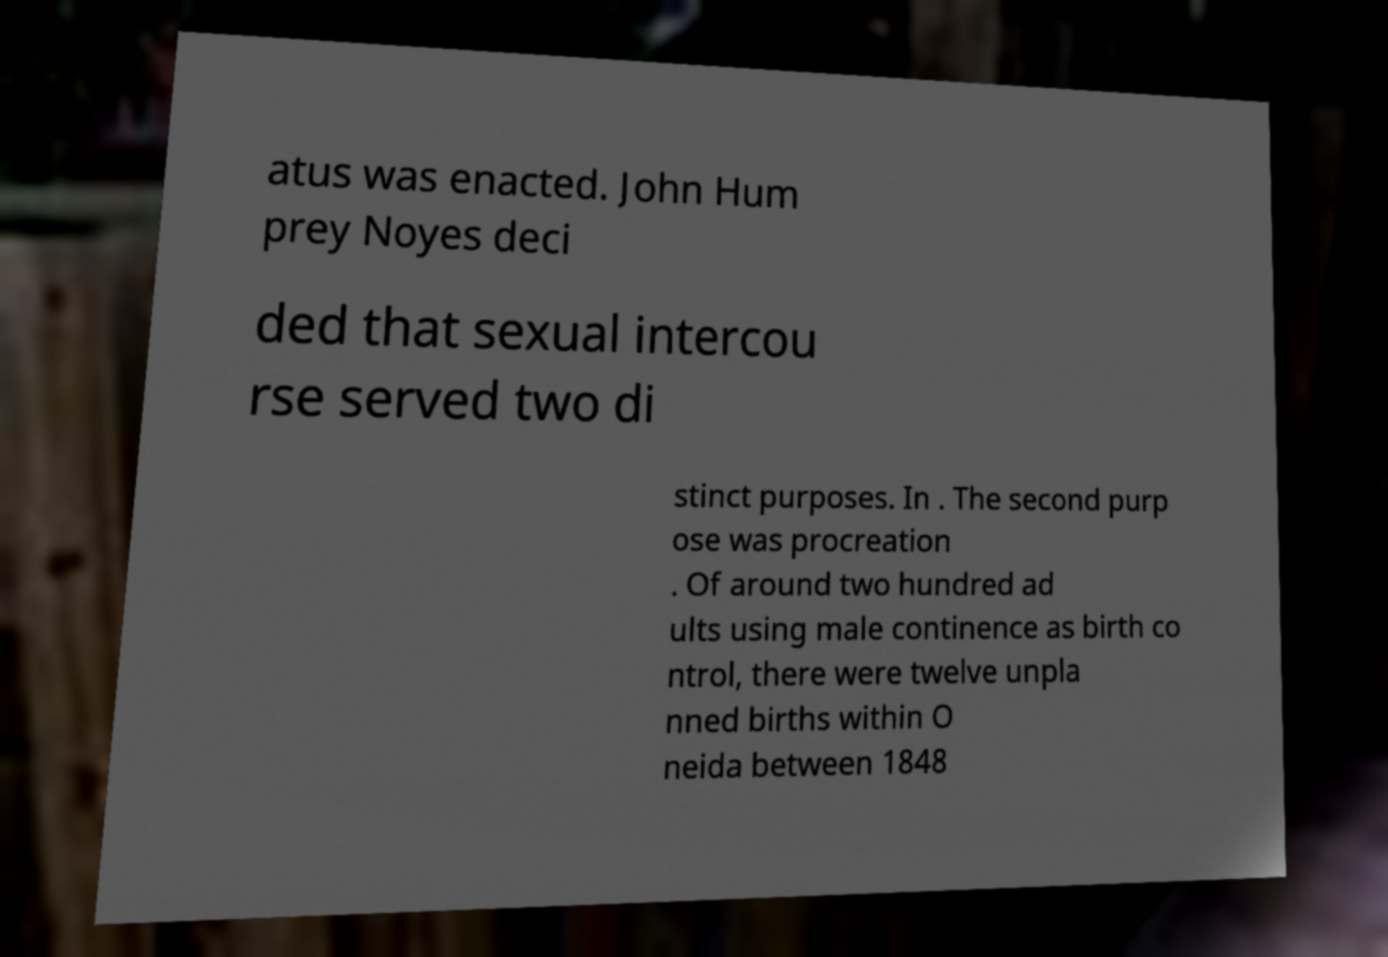What messages or text are displayed in this image? I need them in a readable, typed format. atus was enacted. John Hum prey Noyes deci ded that sexual intercou rse served two di stinct purposes. In . The second purp ose was procreation . Of around two hundred ad ults using male continence as birth co ntrol, there were twelve unpla nned births within O neida between 1848 